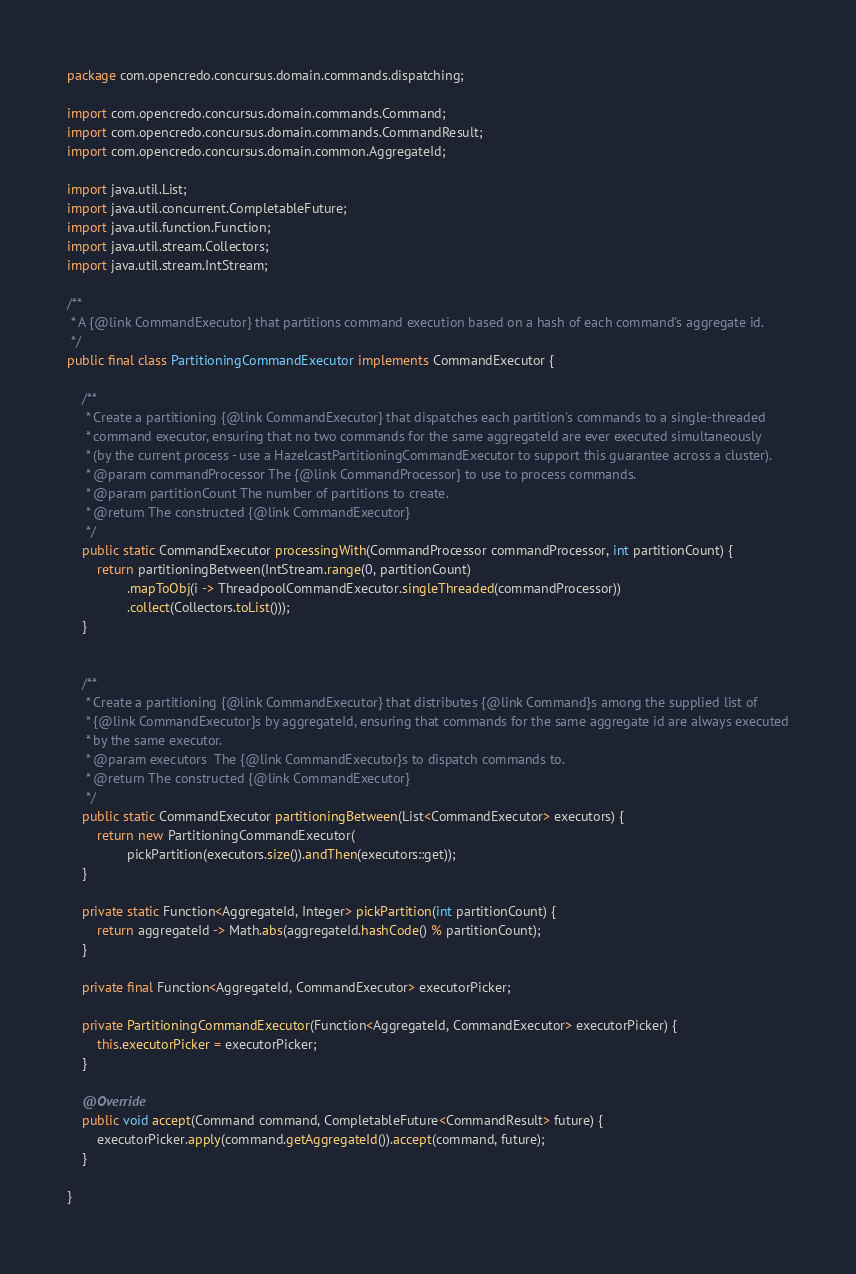Convert code to text. <code><loc_0><loc_0><loc_500><loc_500><_Java_>package com.opencredo.concursus.domain.commands.dispatching;

import com.opencredo.concursus.domain.commands.Command;
import com.opencredo.concursus.domain.commands.CommandResult;
import com.opencredo.concursus.domain.common.AggregateId;

import java.util.List;
import java.util.concurrent.CompletableFuture;
import java.util.function.Function;
import java.util.stream.Collectors;
import java.util.stream.IntStream;

/**
 * A {@link CommandExecutor} that partitions command execution based on a hash of each command's aggregate id.
 */
public final class PartitioningCommandExecutor implements CommandExecutor {

    /**
     * Create a partitioning {@link CommandExecutor} that dispatches each partition's commands to a single-threaded
     * command executor, ensuring that no two commands for the same aggregateId are ever executed simultaneously
     * (by the current process - use a HazelcastPartitioningCommandExecutor to support this guarantee across a cluster).
     * @param commandProcessor The {@link CommandProcessor} to use to process commands.
     * @param partitionCount The number of partitions to create.
     * @return The constructed {@link CommandExecutor}
     */
    public static CommandExecutor processingWith(CommandProcessor commandProcessor, int partitionCount) {
        return partitioningBetween(IntStream.range(0, partitionCount)
                .mapToObj(i -> ThreadpoolCommandExecutor.singleThreaded(commandProcessor))
                .collect(Collectors.toList()));
    }


    /**
     * Create a partitioning {@link CommandExecutor} that distributes {@link Command}s among the supplied list of
     * {@link CommandExecutor}s by aggregateId, ensuring that commands for the same aggregate id are always executed
     * by the same executor.
     * @param executors  The {@link CommandExecutor}s to dispatch commands to.
     * @return The constructed {@link CommandExecutor}
     */
    public static CommandExecutor partitioningBetween(List<CommandExecutor> executors) {
        return new PartitioningCommandExecutor(
                pickPartition(executors.size()).andThen(executors::get));
    }

    private static Function<AggregateId, Integer> pickPartition(int partitionCount) {
        return aggregateId -> Math.abs(aggregateId.hashCode() % partitionCount);
    }

    private final Function<AggregateId, CommandExecutor> executorPicker;

    private PartitioningCommandExecutor(Function<AggregateId, CommandExecutor> executorPicker) {
        this.executorPicker = executorPicker;
    }

    @Override
    public void accept(Command command, CompletableFuture<CommandResult> future) {
        executorPicker.apply(command.getAggregateId()).accept(command, future);
    }

}
</code> 